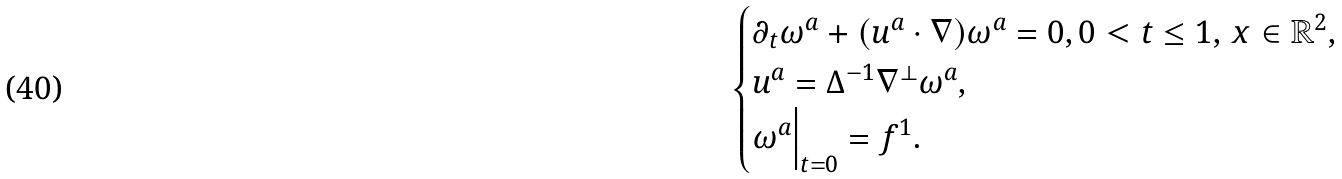<formula> <loc_0><loc_0><loc_500><loc_500>\begin{cases} \partial _ { t } { \omega ^ { a } } + ( u ^ { a } \cdot \nabla ) { \omega ^ { a } } = 0 , 0 < t \leq 1 , \, x \in \mathbb { R } ^ { 2 } , \\ u ^ { a } = \Delta ^ { - 1 } \nabla ^ { \perp } \omega ^ { a } , \\ \omega ^ { a } \Big | _ { t = 0 } = f ^ { 1 } . \end{cases}</formula> 